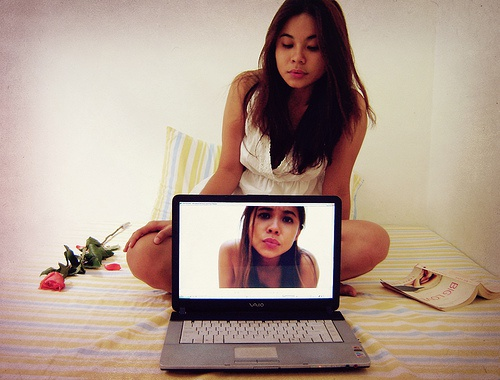Describe the objects in this image and their specific colors. I can see bed in gray, tan, darkgray, and lightgray tones, laptop in gray, ivory, black, and brown tones, people in gray, black, brown, and maroon tones, people in gray, brown, black, maroon, and tan tones, and book in gray and tan tones in this image. 